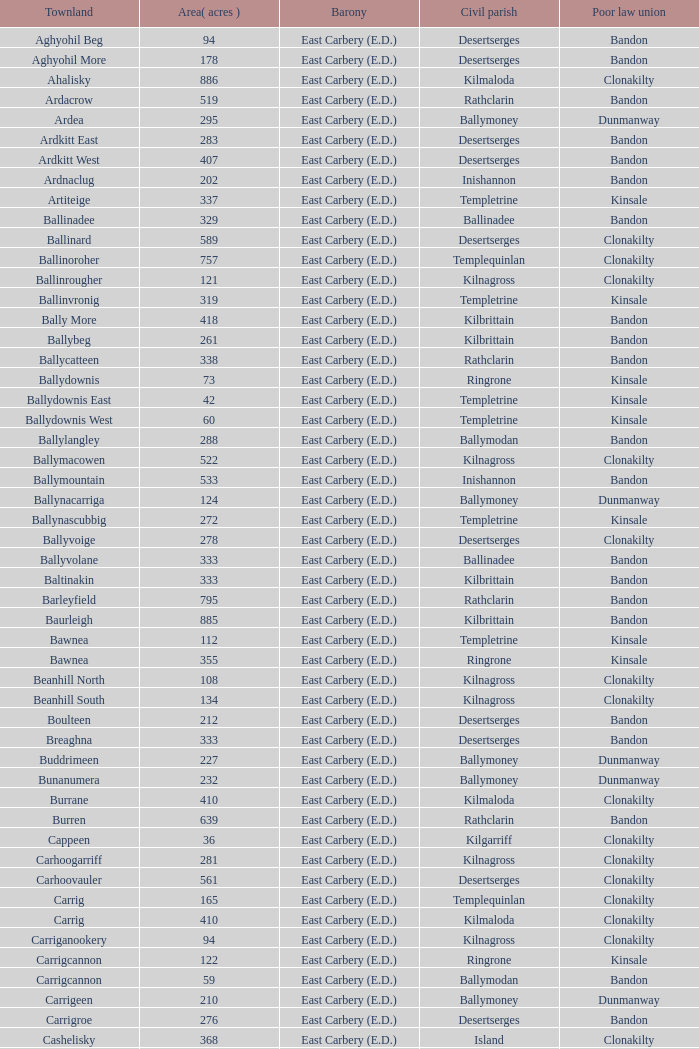What is the poor law federation of the lackenagobidane townland? Clonakilty. 